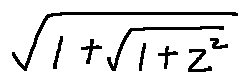Convert formula to latex. <formula><loc_0><loc_0><loc_500><loc_500>\sqrt { 1 + \sqrt { 1 + z ^ { 2 } } }</formula> 